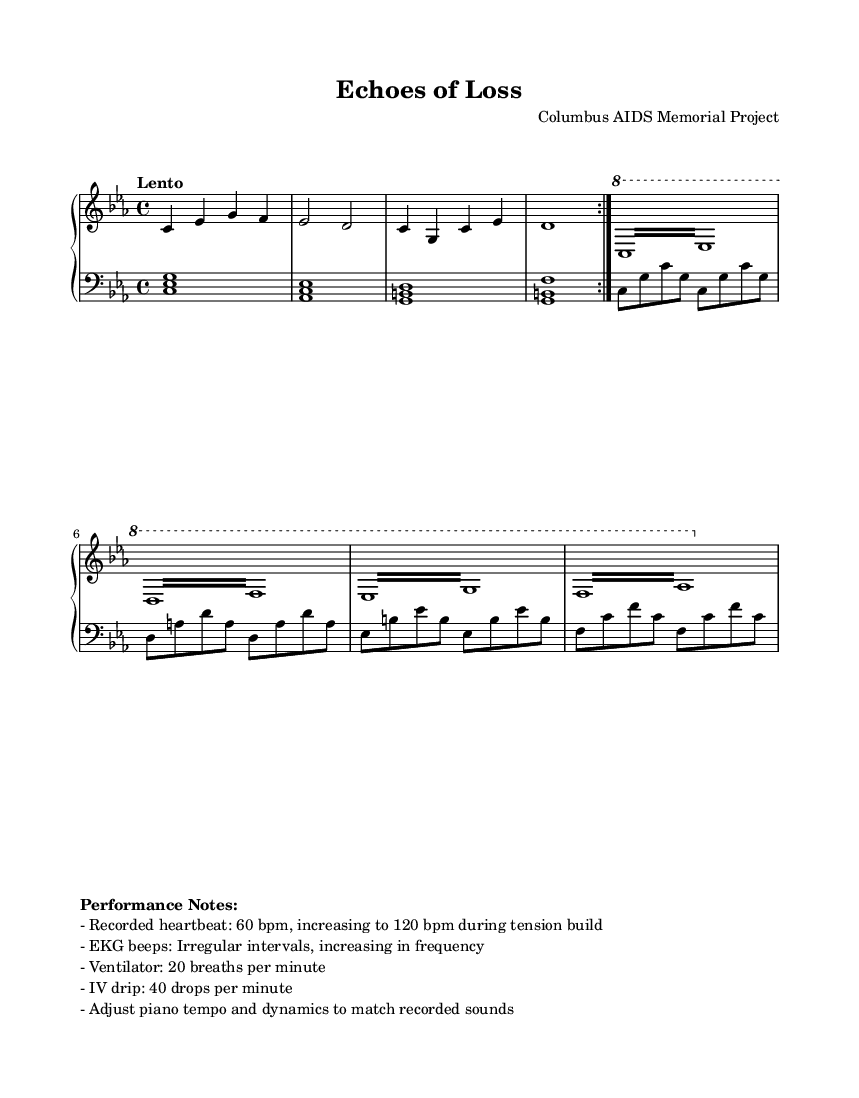What is the key signature of this music? The key signature is indicated in the global settings of the music, which shows that it is in C minor, indicated by the presence of three flats (B, E, and A).
Answer: C minor What is the time signature of the piece? The time signature appears at the beginning of the global section of the score and is noted as 4/4, which means there are four beats per measure.
Answer: 4/4 What tempo marking is used in this score? The tempo marking "Lento" is shown in the global section, indicating a slow tempo for the piece.
Answer: Lento How many repetitions are indicated for the main theme? The main theme is marked with a "volta" designation and is noted to be repeated two times, which can be deduced from the repeated sections in both staves.
Answer: 2 What is the initial recorded heartbeat BPM? The performance notes mention that the recorded heartbeat starts at 60 BPM, which can be directly interpreted from the performance notes provided.
Answer: 60 Which medical sounds are incorporated into the piece? The performance notes specify that there are multiple medical sounds, such as heartbeat, EKG beeps, ventilator sounds, and IV drip sounds. These can be enumerated as specified in the notes.
Answer: Heartbeat, EKG beeps, ventilator, IV drip What dynamic adjustment is suggested for piano? The performance notes indicate that the pianist should adjust the tempo and dynamics to match the recorded medical sounds, suggesting a need for flexibility in performance.
Answer: Adjust to match recorded sounds 